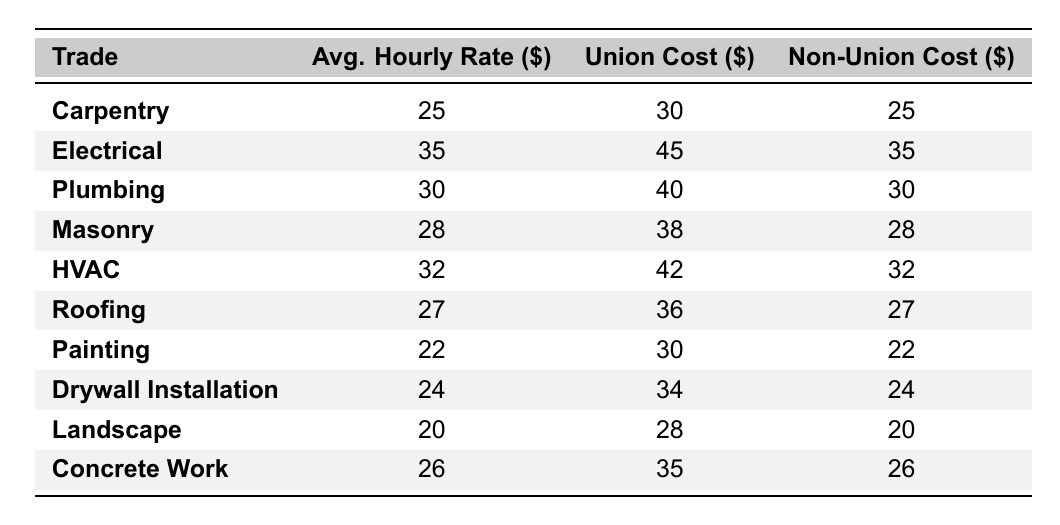What is the average hourly rate for Plumbing? The table shows that the average hourly rate for Plumbing is listed directly under the "Avg. Hourly Rate" column. For Plumbing, this value is 30.
Answer: 30 Which trade has the highest union cost? By comparing the union costs listed in the table, Electrical has the highest union cost at 45.
Answer: Electrical What is the difference between the union cost and non-union cost for Roofing? To find the difference, subtract the non-union cost (27) from the union cost (36) for Roofing. The calculation is 36 - 27 = 9.
Answer: 9 What is the average hourly rate for all trades listed? To calculate the average, sum all the average hourly rates (25 + 35 + 30 + 28 + 32 + 27 + 22 + 24 + 20 + 26 =  9) and divide by the number of trades, which is 10. The total is  9, so the average is  9/10 = 27.
Answer: 27 Is the non-union cost for Carpentry higher than the average hourly rate for Painting? The non-union cost for Carpentry is 25, while the average hourly rate for Painting is 22. Since 25 is greater than 22, the answer is yes.
Answer: Yes What is the lowest average hourly rate among the trades? By examining the average hourly rates for each trade, Landscape has the lowest rate at 20.
Answer: 20 Which two trades have the same non-union cost? Comparing the non-union costs, both Carpentry and Painting have a non-union cost of 25.
Answer: Carpentry and Painting How much more does the union cost for HVAC exceed the non-union cost? The union cost for HVAC is 42 and the non-union cost is 32. The difference is calculated as 42 - 32 = 10.
Answer: 10 What is the total of the average hourly rates for all trades? Adding the average hourly rates (25 + 35 + 30 + 28 + 32 + 27 + 22 + 24 + 20 + 26 =  9) results in a total of  9.
Answer: 9 True or False: Painting has a higher union cost than Masonry. The union cost for Painting is 30, while Masonry's union cost is 38. Therefore, Painting does not exceed Masonry's union cost, making the statement false.
Answer: False 